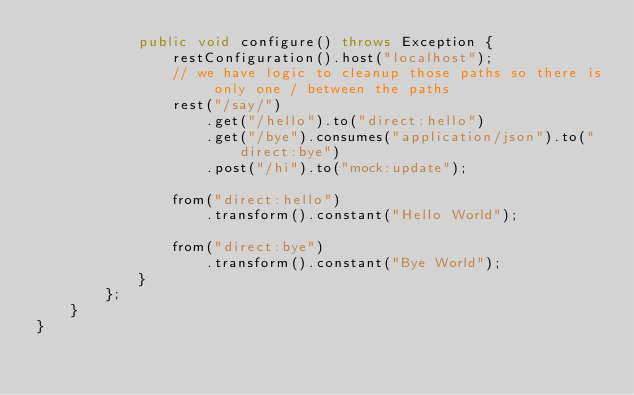<code> <loc_0><loc_0><loc_500><loc_500><_Java_>            public void configure() throws Exception {
                restConfiguration().host("localhost");
                // we have logic to cleanup those paths so there is only one / between the paths
                rest("/say/")
                    .get("/hello").to("direct:hello")
                    .get("/bye").consumes("application/json").to("direct:bye")
                    .post("/hi").to("mock:update");

                from("direct:hello")
                    .transform().constant("Hello World");

                from("direct:bye")
                    .transform().constant("Bye World");
            }
        };
    }
}
</code> 